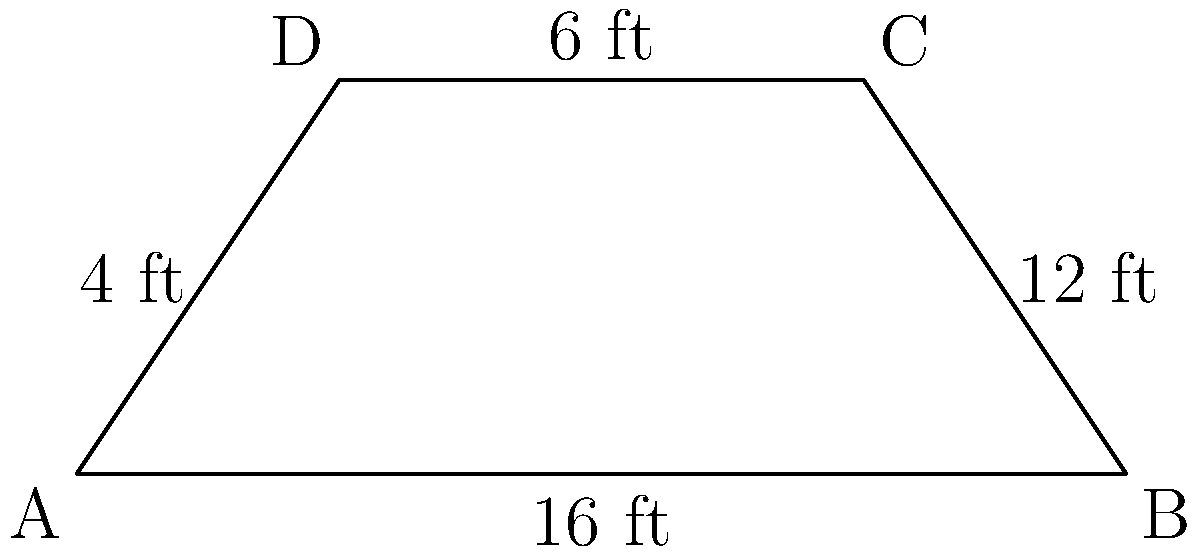On a basketball court, there's a trapezoid-shaped key (painted area) as shown in the diagram. If the baseline (bottom) of the trapezoid is 16 feet, the top is 12 feet, and the height is 6 feet, what is the area of this key in square feet? To find the area of a trapezoid, we can use the formula:

$$A = \frac{1}{2}(b_1 + b_2)h$$

Where:
$A$ = Area
$b_1$ = Length of one parallel side
$b_2$ = Length of the other parallel side
$h$ = Height (perpendicular distance between the parallel sides)

Given:
$b_1 = 16$ feet (baseline)
$b_2 = 12$ feet (top)
$h = 6$ feet (height)

Let's substitute these values into the formula:

$$A = \frac{1}{2}(16 + 12) \times 6$$

$$A = \frac{1}{2}(28) \times 6$$

$$A = 14 \times 6$$

$$A = 84$$

Therefore, the area of the trapezoid-shaped key is 84 square feet.
Answer: 84 sq ft 